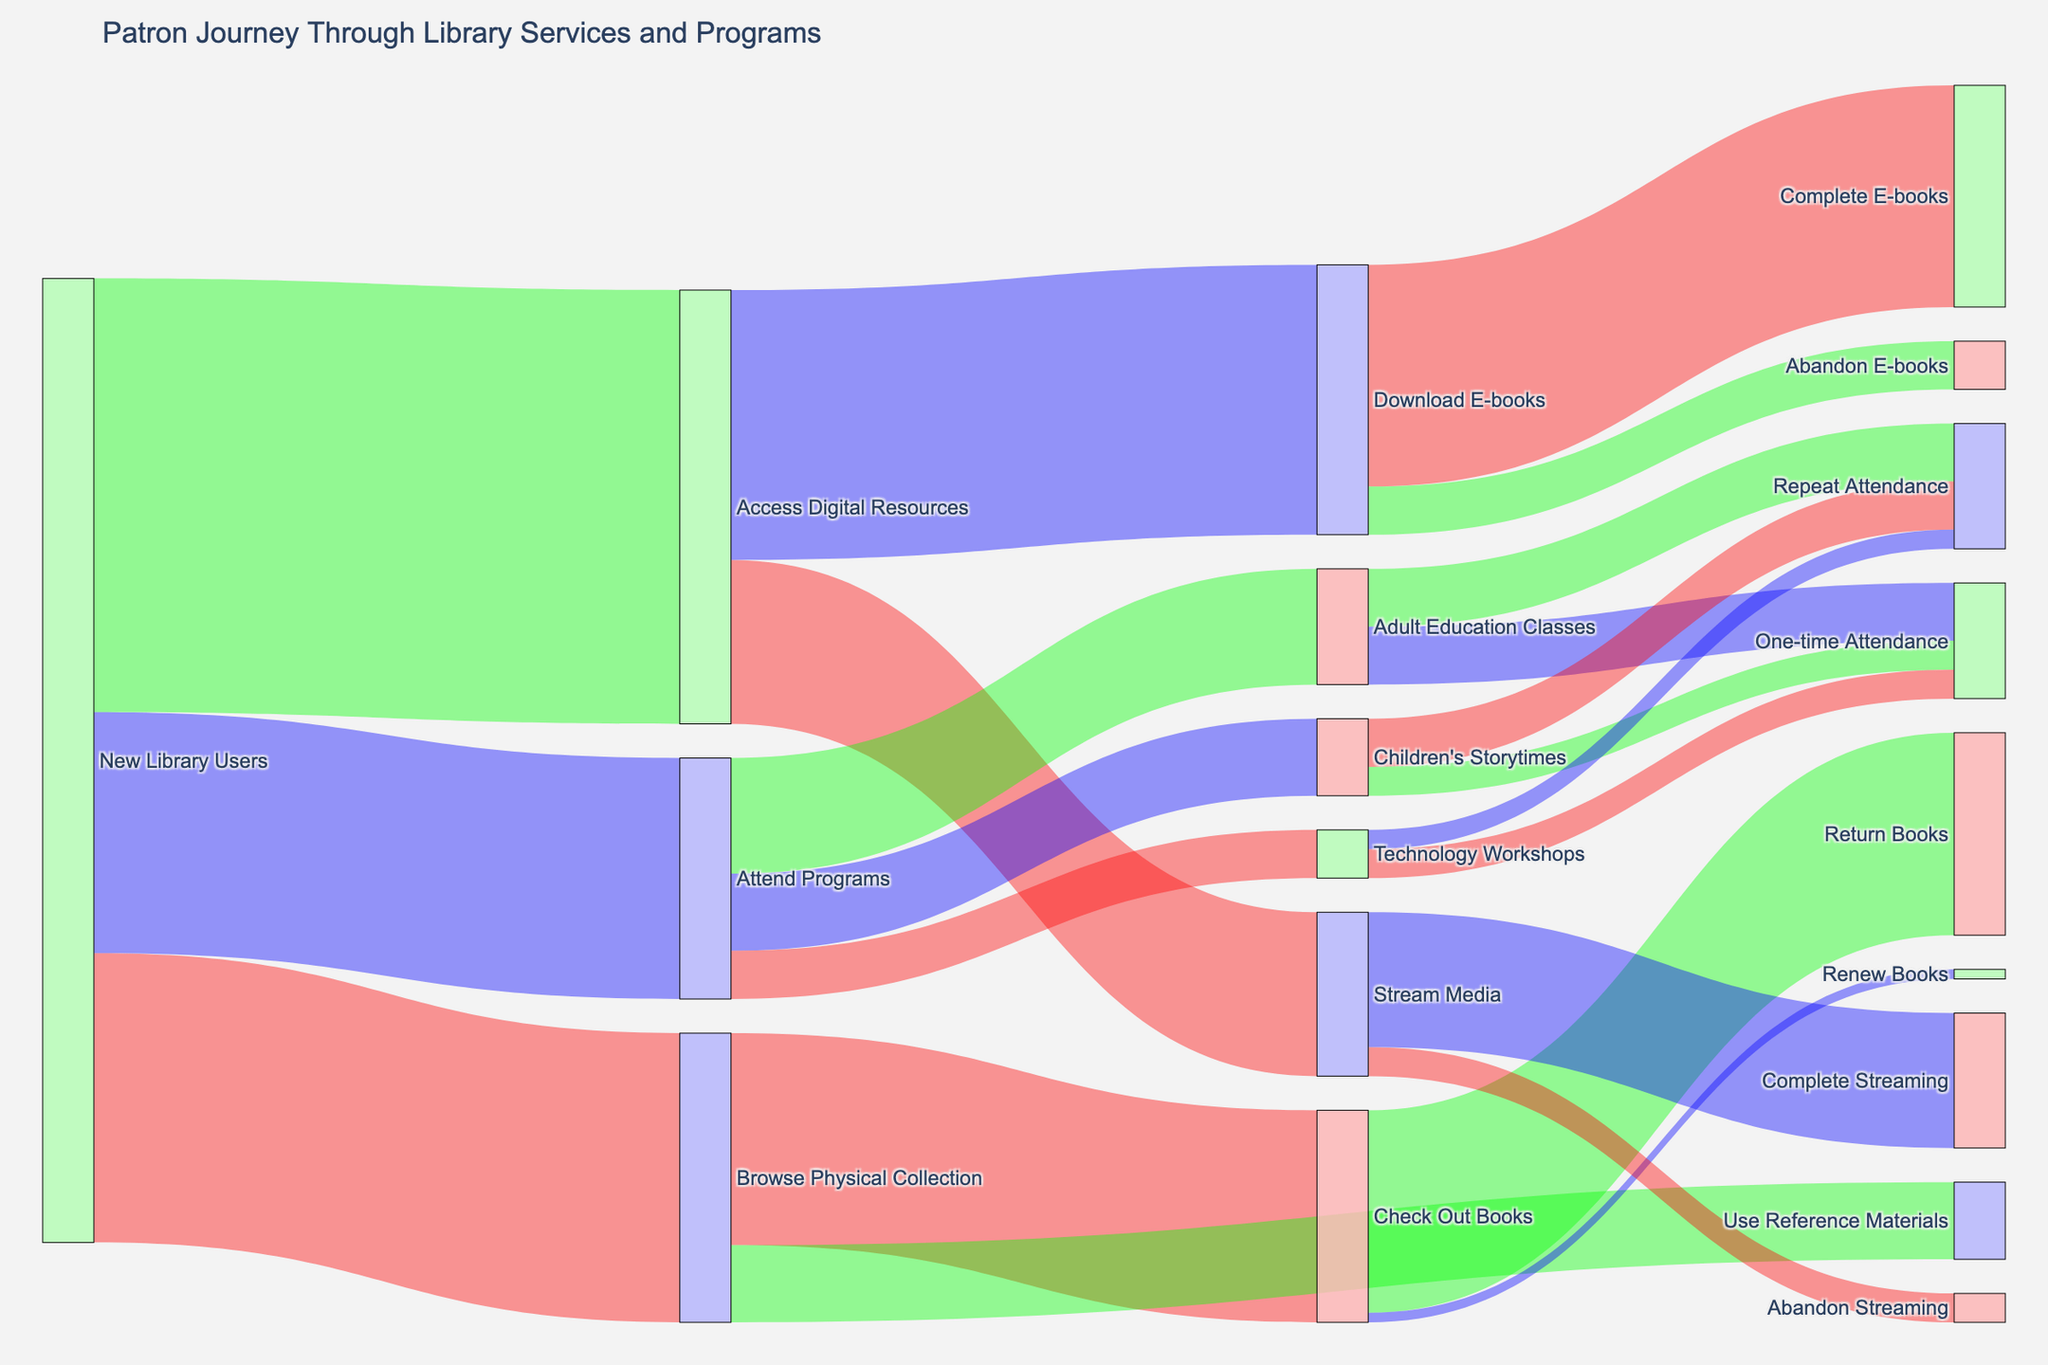How many new library users attended programs? Look at the flow from "New Library Users" to "Attend Programs," which shows a value of 2,500.
Answer: 2,500 Which service experiences the highest number of engagements from new library users? Compare the values flowing from "New Library Users" to various services like "Browse Physical Collection," "Access Digital Resources," and "Attend Programs." The highest value is 4,500 for "Access Digital Resources."
Answer: Access Digital Resources What is the combined total of new library users who browsed the physical collection and accessed digital resources? Add the values from "New Library Users" to "Browse Physical Collection" (3,000) and "Access Digital Resources" (4,500), resulting in a total of 7,500.
Answer: 7,500 What percentage of library users who download e-books actually complete them? Calculate the proportion of "Download E-books" (2,800) that lead to "Complete E-books" (2,300). This is (2,300 / 2,800) * 100 ≈ 82.14%.
Answer: 82.14% How many patrons abandoned streaming media? Look at the flow from "Stream Media" to "Abandon Streaming," which shows a value of 300.
Answer: 300 Which type of attendance is more common for adult education classes, repeat or one-time? Compare the values of "Repeat Attendance" (600) and "One-time Attendance" (600) for "Adult Education Classes." Both are equal at 600.
Answer: Both are equal Is checking out or renewing books a more common activity after browsing the physical collection? Compare the values for "Check Out Books" (2,200) and "Use Reference Materials" (800) from "Browse Physical Collection." Checking out books is more common.
Answer: Check Out Books How many patrons attended children's storytimes more than once? Look at the flow from "Children's Storytimes" to "Repeat Attendance," which shows a value of 500.
Answer: 500 What percentage of patrons who attended technology workshops did so only once? Calculate the proportion of "Technology Workshops" (500) leading to "One-time Attendance" (300). This is (300 / 500) * 100 = 60%.
Answer: 60% What is the final outcome for most patrons who check out books? Compare the values of "Return Books" (2,100) and "Renew Books" (100) from "Check Out Books." Returning books is the more common outcome.
Answer: Return Books 